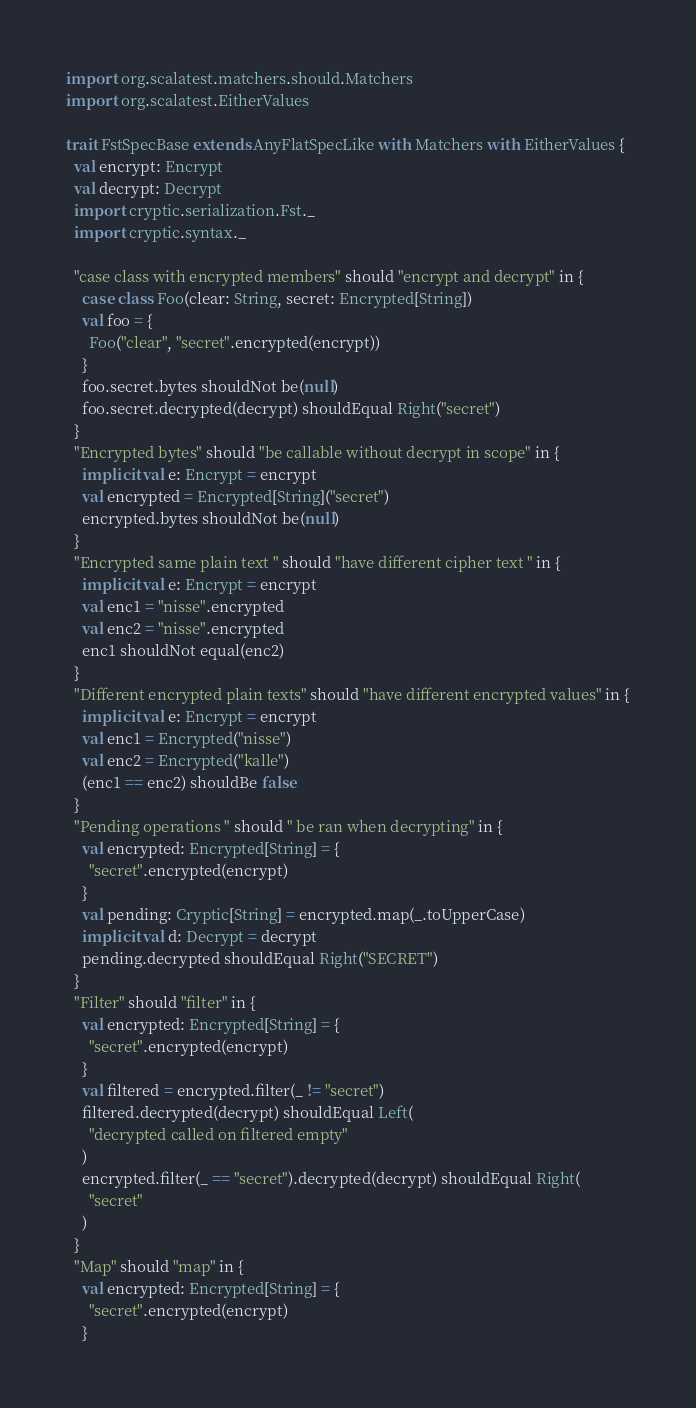<code> <loc_0><loc_0><loc_500><loc_500><_Scala_>import org.scalatest.matchers.should.Matchers
import org.scalatest.EitherValues

trait FstSpecBase extends AnyFlatSpecLike with Matchers with EitherValues {
  val encrypt: Encrypt
  val decrypt: Decrypt
  import cryptic.serialization.Fst._
  import cryptic.syntax._

  "case class with encrypted members" should "encrypt and decrypt" in {
    case class Foo(clear: String, secret: Encrypted[String])
    val foo = {
      Foo("clear", "secret".encrypted(encrypt))
    }
    foo.secret.bytes shouldNot be(null)
    foo.secret.decrypted(decrypt) shouldEqual Right("secret")
  }
  "Encrypted bytes" should "be callable without decrypt in scope" in {
    implicit val e: Encrypt = encrypt
    val encrypted = Encrypted[String]("secret")
    encrypted.bytes shouldNot be(null)
  }
  "Encrypted same plain text " should "have different cipher text " in {
    implicit val e: Encrypt = encrypt
    val enc1 = "nisse".encrypted
    val enc2 = "nisse".encrypted
    enc1 shouldNot equal(enc2)
  }
  "Different encrypted plain texts" should "have different encrypted values" in {
    implicit val e: Encrypt = encrypt
    val enc1 = Encrypted("nisse")
    val enc2 = Encrypted("kalle")
    (enc1 == enc2) shouldBe false
  }
  "Pending operations " should " be ran when decrypting" in {
    val encrypted: Encrypted[String] = {
      "secret".encrypted(encrypt)
    }
    val pending: Cryptic[String] = encrypted.map(_.toUpperCase)
    implicit val d: Decrypt = decrypt
    pending.decrypted shouldEqual Right("SECRET")
  }
  "Filter" should "filter" in {
    val encrypted: Encrypted[String] = {
      "secret".encrypted(encrypt)
    }
    val filtered = encrypted.filter(_ != "secret")
    filtered.decrypted(decrypt) shouldEqual Left(
      "decrypted called on filtered empty"
    )
    encrypted.filter(_ == "secret").decrypted(decrypt) shouldEqual Right(
      "secret"
    )
  }
  "Map" should "map" in {
    val encrypted: Encrypted[String] = {
      "secret".encrypted(encrypt)
    }</code> 